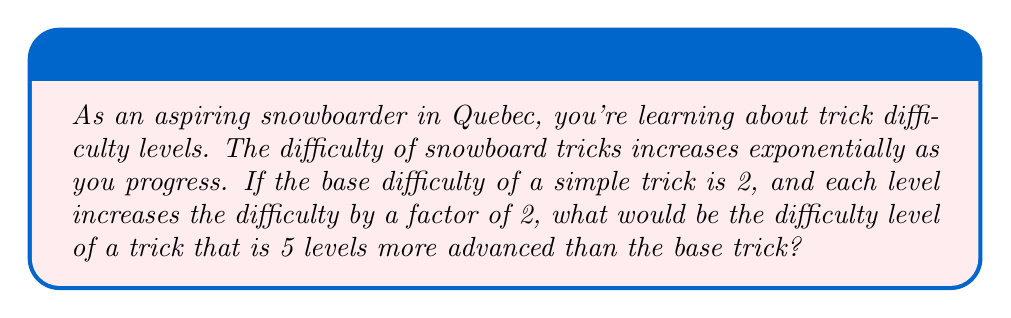Help me with this question. Let's approach this step-by-step:

1) We start with a base difficulty of 2.

2) Each level increases the difficulty by a factor of 2. This means we're dealing with exponential growth.

3) We can represent this mathematically as:

   $$ \text{Difficulty} = 2 \cdot 2^n $$

   Where $n$ is the number of levels above the base trick.

4) In this case, we're looking at a trick that is 5 levels more advanced, so $n = 5$.

5) Let's plug this into our equation:

   $$ \text{Difficulty} = 2 \cdot 2^5 $$

6) Now, let's calculate $2^5$:
   
   $$ 2^5 = 2 \cdot 2 \cdot 2 \cdot 2 \cdot 2 = 32 $$

7) So our equation becomes:

   $$ \text{Difficulty} = 2 \cdot 32 = 64 $$

Therefore, a trick that is 5 levels more advanced than the base trick would have a difficulty level of 64.
Answer: The difficulty level of the trick would be 64. 